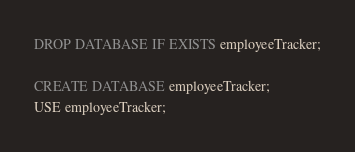<code> <loc_0><loc_0><loc_500><loc_500><_SQL_>DROP DATABASE IF EXISTS employeeTracker;

CREATE DATABASE employeeTracker;
USE employeeTracker;</code> 